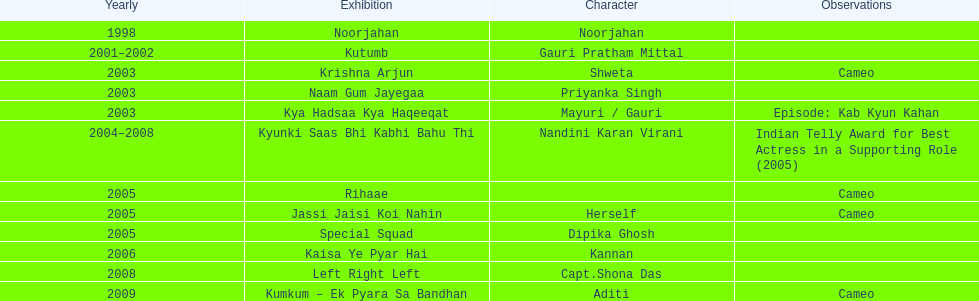Which television show was gauri in for the longest amount of time? Kyunki Saas Bhi Kabhi Bahu Thi. 